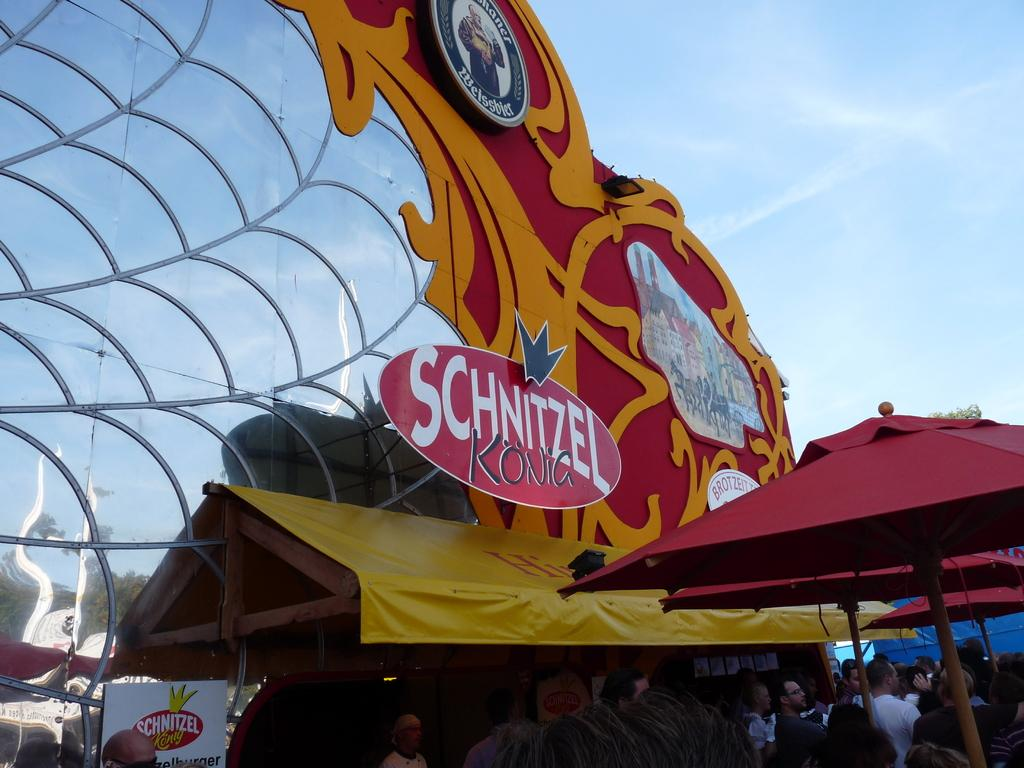<image>
Provide a brief description of the given image. A sign for Schnitzel Konig Weissbier in the outdoors 